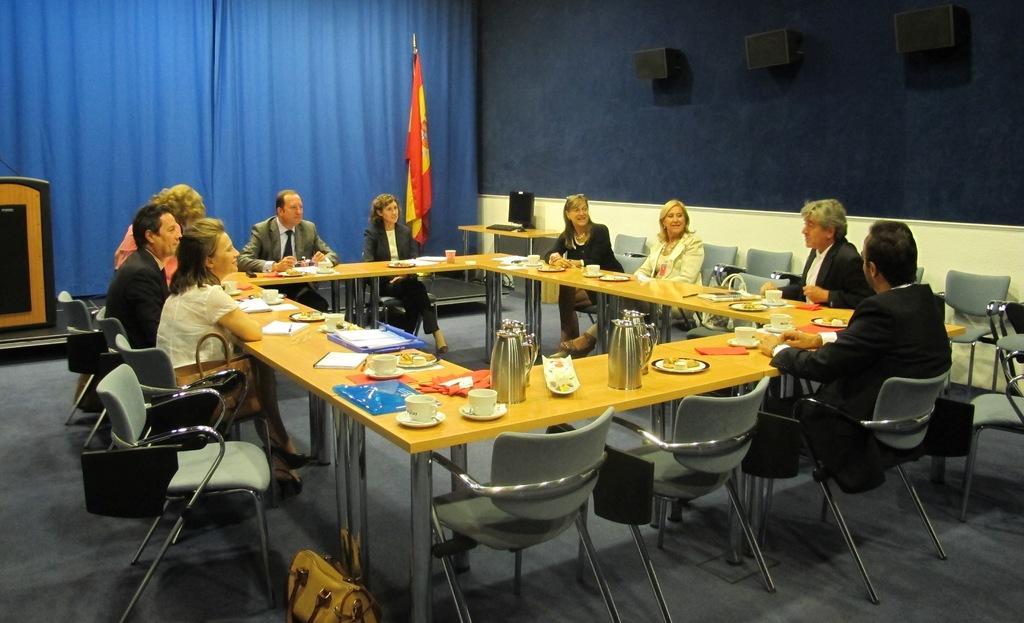How would you summarize this image in a sentence or two? In this picture we can see people are sitting on chairs. In-front of them there are tables, on these tables there are cups, books and things. Speakers are on the blue wall. In-front of that wall there is a table, above the table there is a keyboard and monitor. Backside of these people there is a blue curtains, flag and podium. On the floor there is a handbag.  